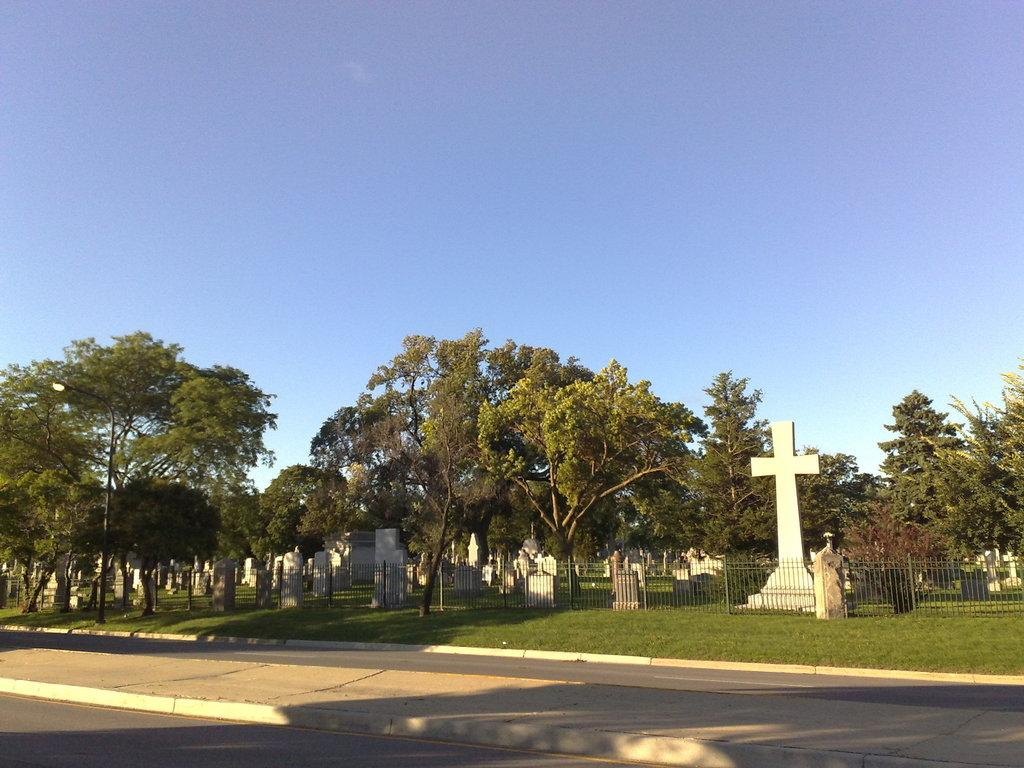What type of area is depicted in the image? The image shows cemeteries. What surrounds the cemeteries in the image? There is fencing around the cemeteries. What type of vegetation can be seen in the image? There are trees in the image. What is the ground covered with in the image? There is grass in the image. What else can be seen in the image besides the cemeteries? There is a road visible in the image. What is the reaction of the cemeteries to the year 2022? The image does not depict a reaction or any indication of time, so it is not possible to answer this question. 